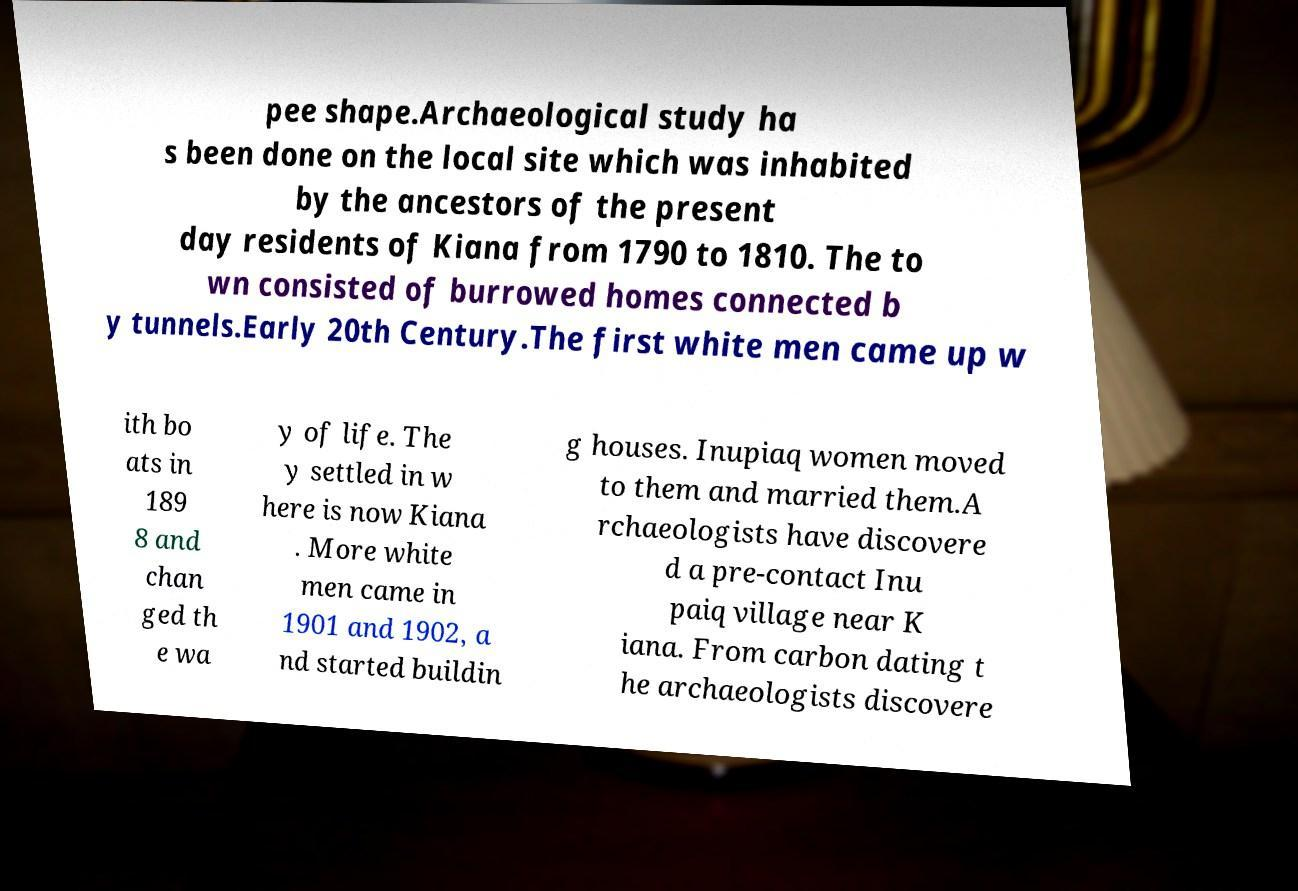Please read and relay the text visible in this image. What does it say? pee shape.Archaeological study ha s been done on the local site which was inhabited by the ancestors of the present day residents of Kiana from 1790 to 1810. The to wn consisted of burrowed homes connected b y tunnels.Early 20th Century.The first white men came up w ith bo ats in 189 8 and chan ged th e wa y of life. The y settled in w here is now Kiana . More white men came in 1901 and 1902, a nd started buildin g houses. Inupiaq women moved to them and married them.A rchaeologists have discovere d a pre-contact Inu paiq village near K iana. From carbon dating t he archaeologists discovere 